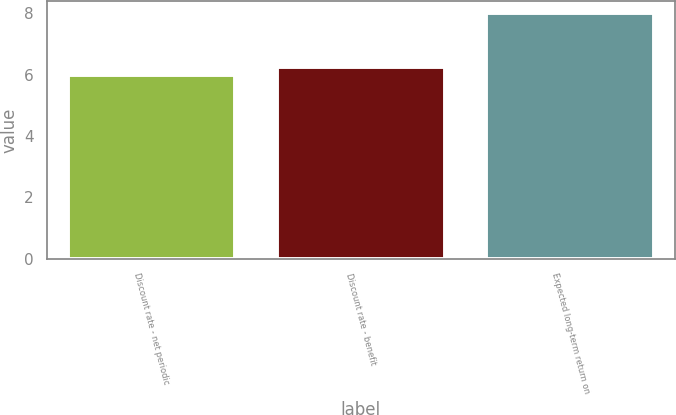<chart> <loc_0><loc_0><loc_500><loc_500><bar_chart><fcel>Discount rate - net periodic<fcel>Discount rate - benefit<fcel>Expected long-term return on<nl><fcel>6<fcel>6.25<fcel>8<nl></chart> 